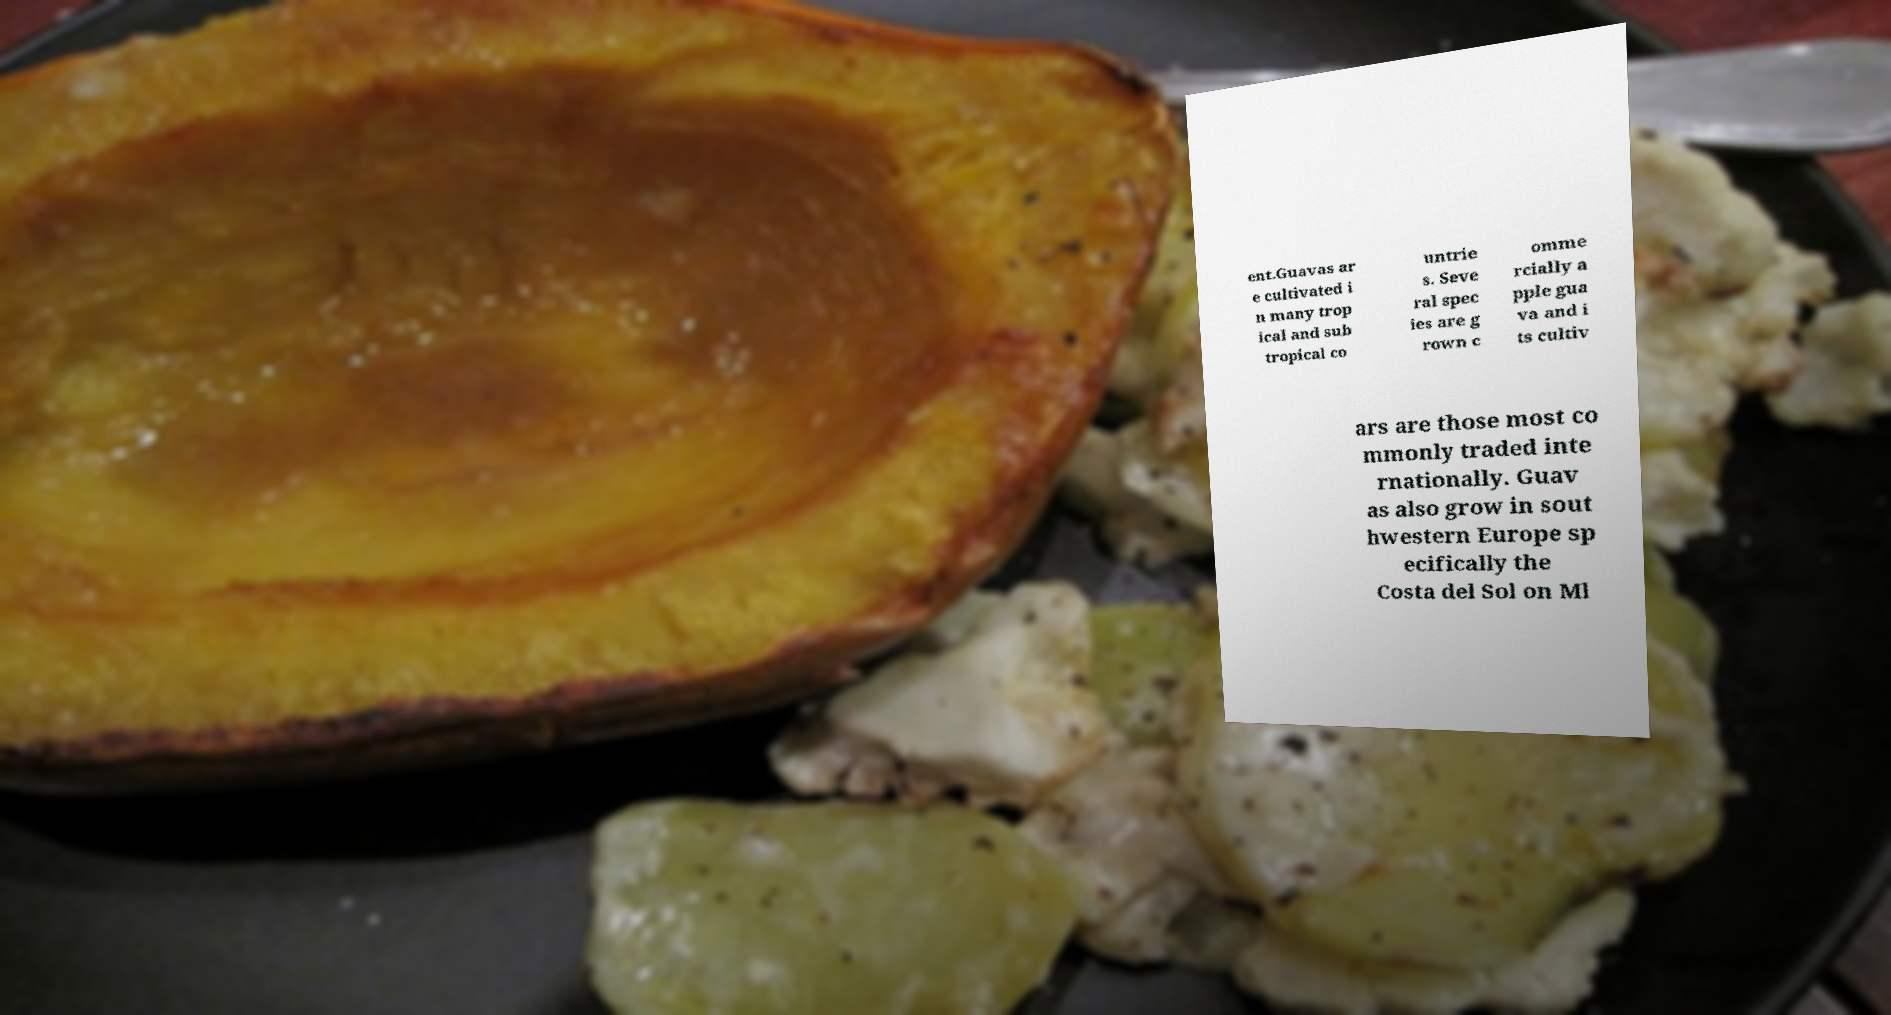Can you tell me more about the origins and cultivation methods of guavas? Guavas originate from an area extending from Mexico through Central America. Today, they are cultivated in many tropical and subtropical regions. The plants thrive in both humid and dry climates and can be grown using various methods, including intensive farming and organic practices. They are typically planted during the rainy season, and fruits are harvested when they mature and soften. 